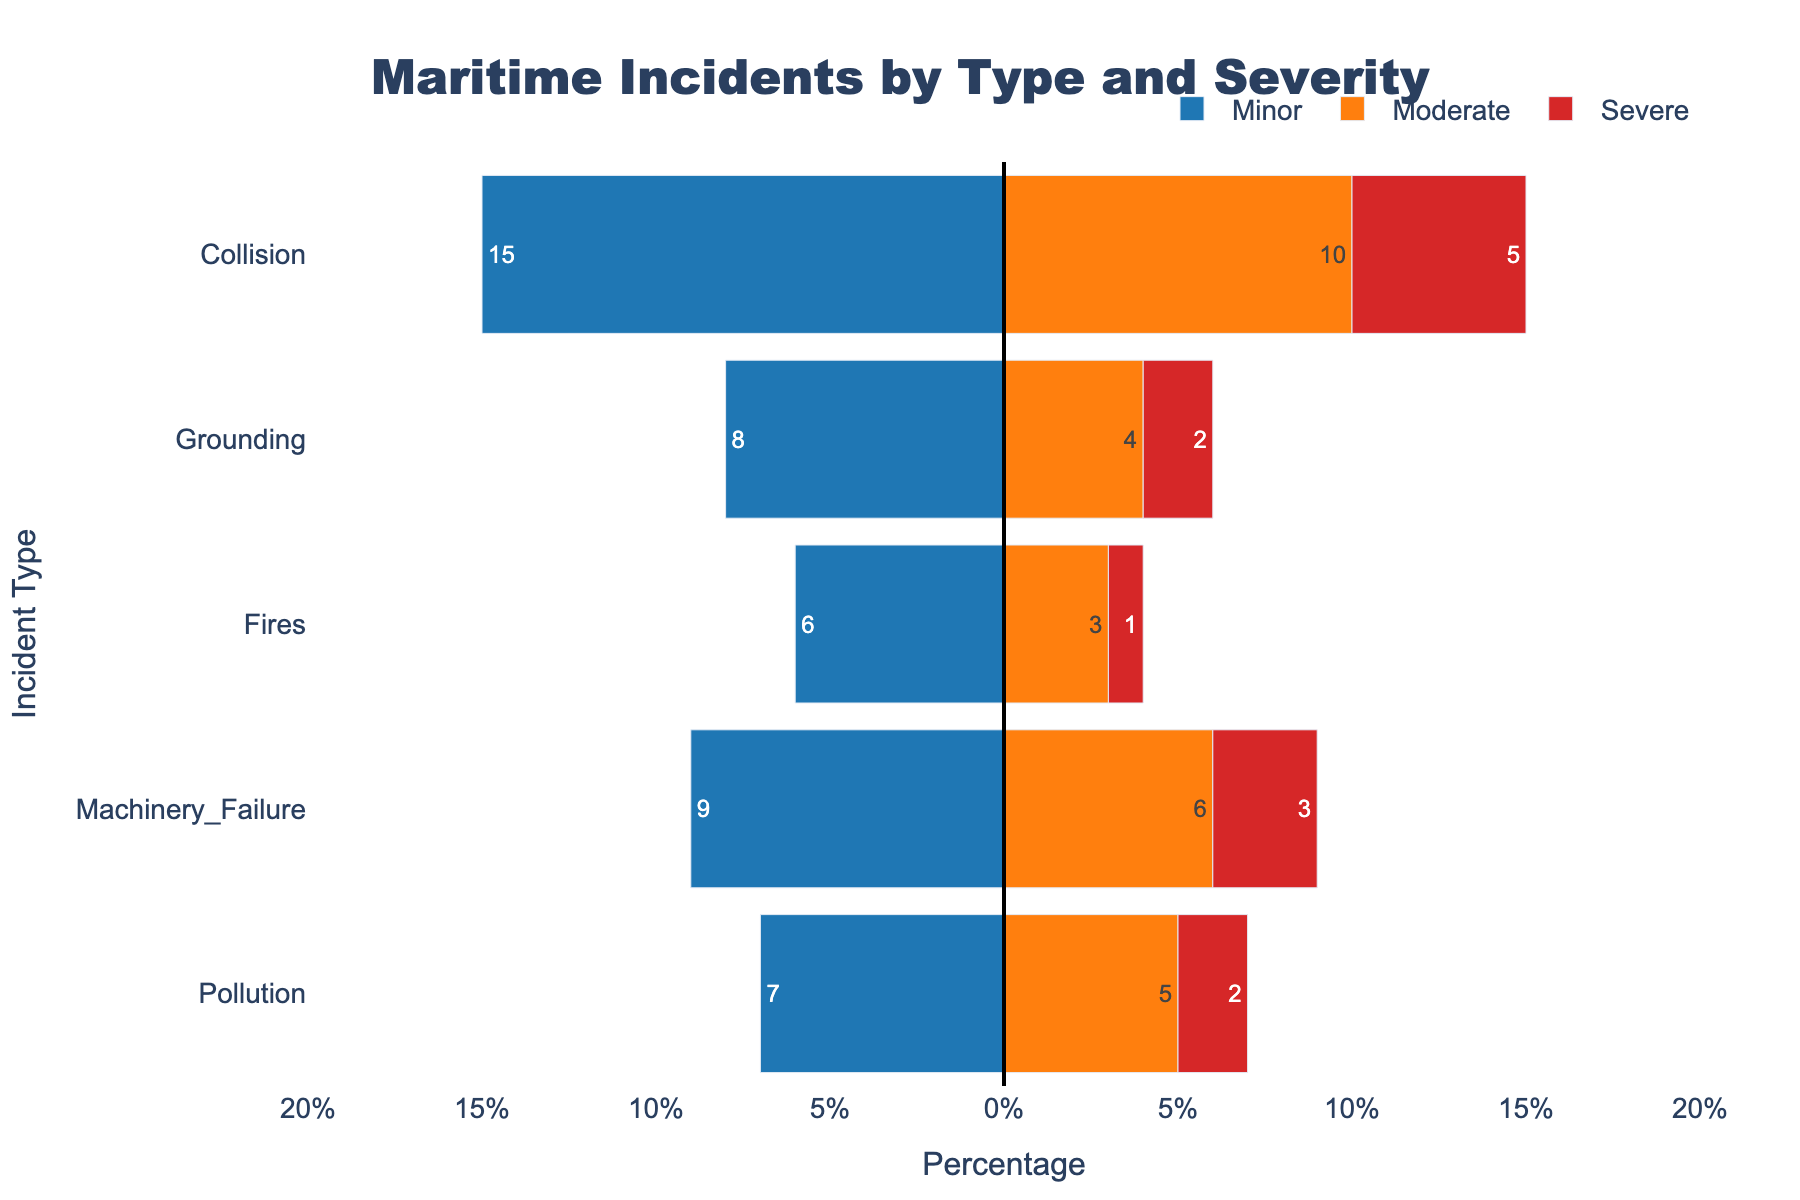What is the total percentage of minor incidents across all incident types? To find the total percentage of minor incidents, sum up the percentages for each category: Collision (15%), Grounding (8%), Fires (6%), Machinery Failure (9%), and Pollution (7%). 15 + 8 + 6 + 9 + 7 = 45
Answer: 45% Which incident type has the highest percentage of severe incidents? Looking at the severe incidents, Collision has 5%, Grounding has 2%, Fires have 1%, Machinery Failure has 3%, and Pollution has 2%. Collision has the highest percentage.
Answer: Collision Are moderate or severe incidents more common overall? Sum the percentages for moderate incidents: Collision (10%), Grounding (4%), Fires (3%), Machinery Failure (6%), and Pollution (5%). 10 + 4 + 3 + 6 + 5 = 28. Sum the percentages for severe incidents: Collision (5%), Grounding (2%), Fires (1%), Machinery Failure (3%), Pollution (2%). 5 + 2 + 1 + 3 + 2 = 13. Moderate incidents (28%) are more common than severe incidents (13%).
Answer: Moderate Which type of incident tends to be more severe, basing on the percentage distribution? Compare the percentages within each incident type for severity. Collision's severe percentage (5%) is notably higher compared to its minor and moderate percentages relative to the others, making it the type where severe incidents are more frequent in comparison to its other severity levels.
Answer: Collision For which incident type is the sum of moderate and severe percentages equal to the highest individual percentage of minor incidents? First, find the sum of moderate and severe percentages for each incident type. Then, compare these to the highest minor percentage, which is 15% for Collision. 
- Collision: 10 + 5 = 15
- Grounding: 4 + 2 = 6
- Fires: 3 + 1 = 4
- Machinery Failure: 6 + 3 = 9
- Pollution: 5 + 2 = 7
Collision's moderate and severe percentages sum up to 15%, matching the highest minor percentage.
Answer: Collision What percentage difference exists between the highest percentage minor incident and the highest percentage severe incident? Collision has the highest percentage minor (15%) and severe (5%) incidents. The difference is 15 - 5 = 10.
Answer: 10% Which severity level is color-coded with the color that has the lowest percentage of incidents? Looking at the color coding, severe incidents use the red color. The total percentage of severe incidents is the lowest among all severities at (5 + 2 + 1 + 3 + 2) = 13%.
Answer: Severe 